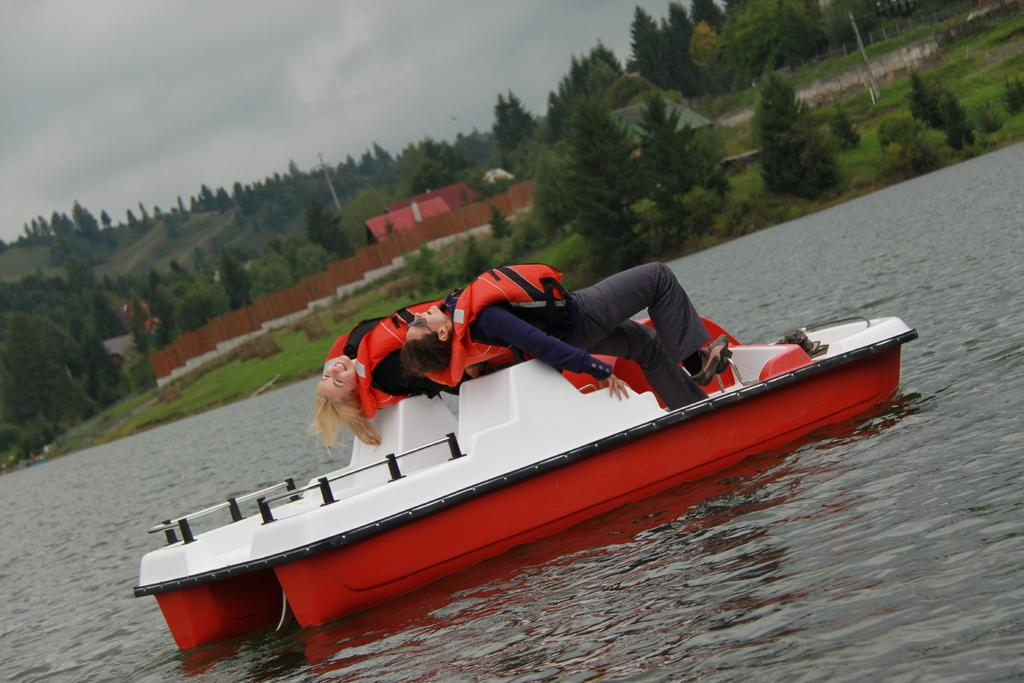How many people are in the image? There are two people in the image. What are the people doing in the image? The people are on a boat. What can be seen at the bottom of the image? There is water visible at the bottom of the image. What is visible in the background of the image? There are trees, buildings, a metal fence, and the sky visible in the background of the image. What type of grain is being harvested by the crow in the image? There is no crow or grain present in the image. 